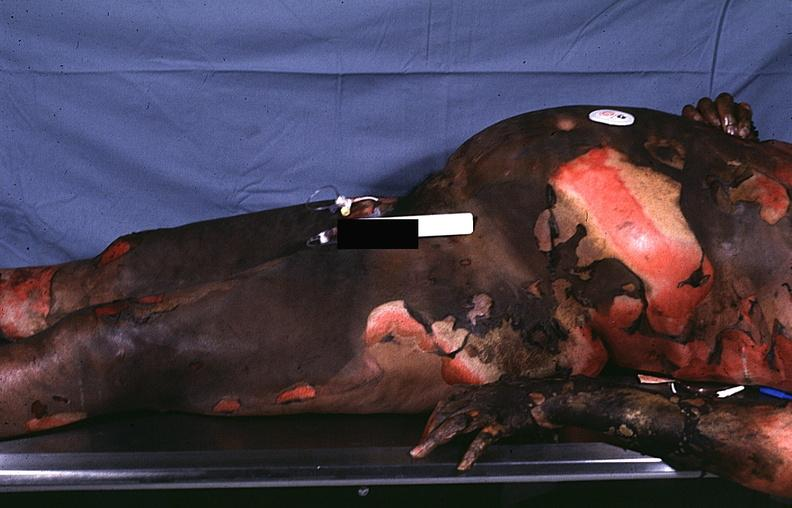do serous cystadenoma burn?
Answer the question using a single word or phrase. No 